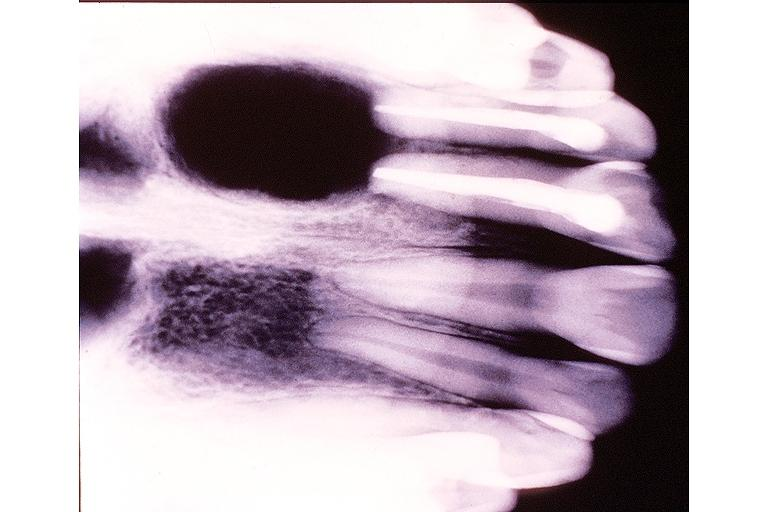what does this image show?
Answer the question using a single word or phrase. Radicular cyst 